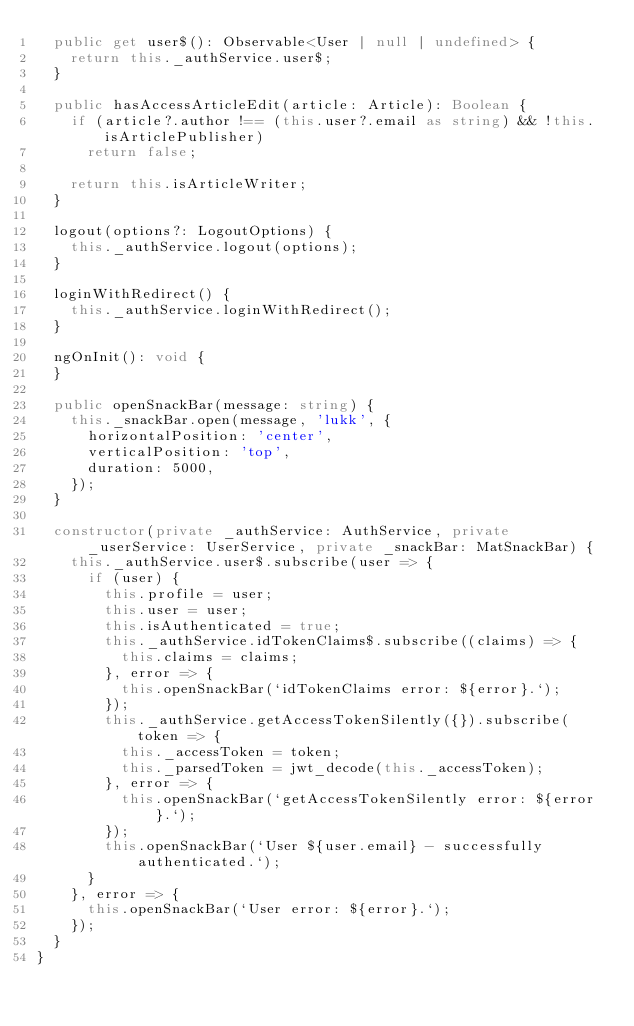<code> <loc_0><loc_0><loc_500><loc_500><_TypeScript_>  public get user$(): Observable<User | null | undefined> {
    return this._authService.user$;
  }

  public hasAccessArticleEdit(article: Article): Boolean {
    if (article?.author !== (this.user?.email as string) && !this.isArticlePublisher)
      return false;

    return this.isArticleWriter;
  }

  logout(options?: LogoutOptions) {
    this._authService.logout(options);
  }

  loginWithRedirect() {
    this._authService.loginWithRedirect();
  }

  ngOnInit(): void {
  }

  public openSnackBar(message: string) {
    this._snackBar.open(message, 'lukk', {
      horizontalPosition: 'center',
      verticalPosition: 'top',
      duration: 5000,
    });
  }

  constructor(private _authService: AuthService, private _userService: UserService, private _snackBar: MatSnackBar) {
    this._authService.user$.subscribe(user => {
      if (user) {
        this.profile = user;
        this.user = user;
        this.isAuthenticated = true;
        this._authService.idTokenClaims$.subscribe((claims) => {
          this.claims = claims;
        }, error => {
          this.openSnackBar(`idTokenClaims error: ${error}.`);
        });
        this._authService.getAccessTokenSilently({}).subscribe(token => {
          this._accessToken = token;
          this._parsedToken = jwt_decode(this._accessToken);
        }, error => {
          this.openSnackBar(`getAccessTokenSilently error: ${error}.`);
        });
        this.openSnackBar(`User ${user.email} - successfully authenticated.`);
      }
    }, error => {
      this.openSnackBar(`User error: ${error}.`);
    });
  }
}
</code> 